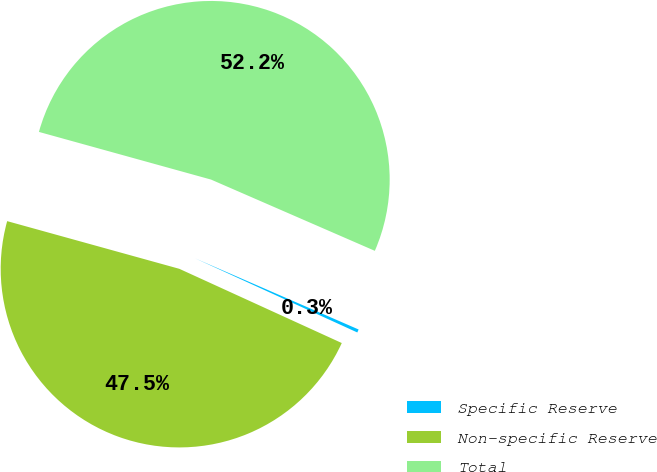<chart> <loc_0><loc_0><loc_500><loc_500><pie_chart><fcel>Specific Reserve<fcel>Non-specific Reserve<fcel>Total<nl><fcel>0.29%<fcel>47.48%<fcel>52.23%<nl></chart> 